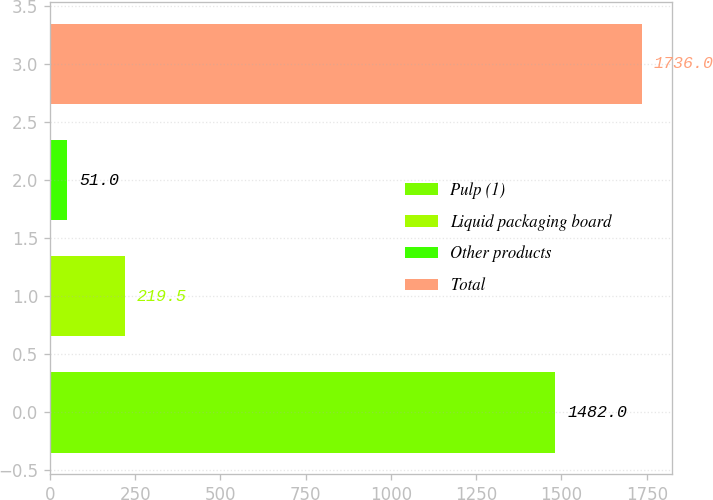Convert chart. <chart><loc_0><loc_0><loc_500><loc_500><bar_chart><fcel>Pulp (1)<fcel>Liquid packaging board<fcel>Other products<fcel>Total<nl><fcel>1482<fcel>219.5<fcel>51<fcel>1736<nl></chart> 